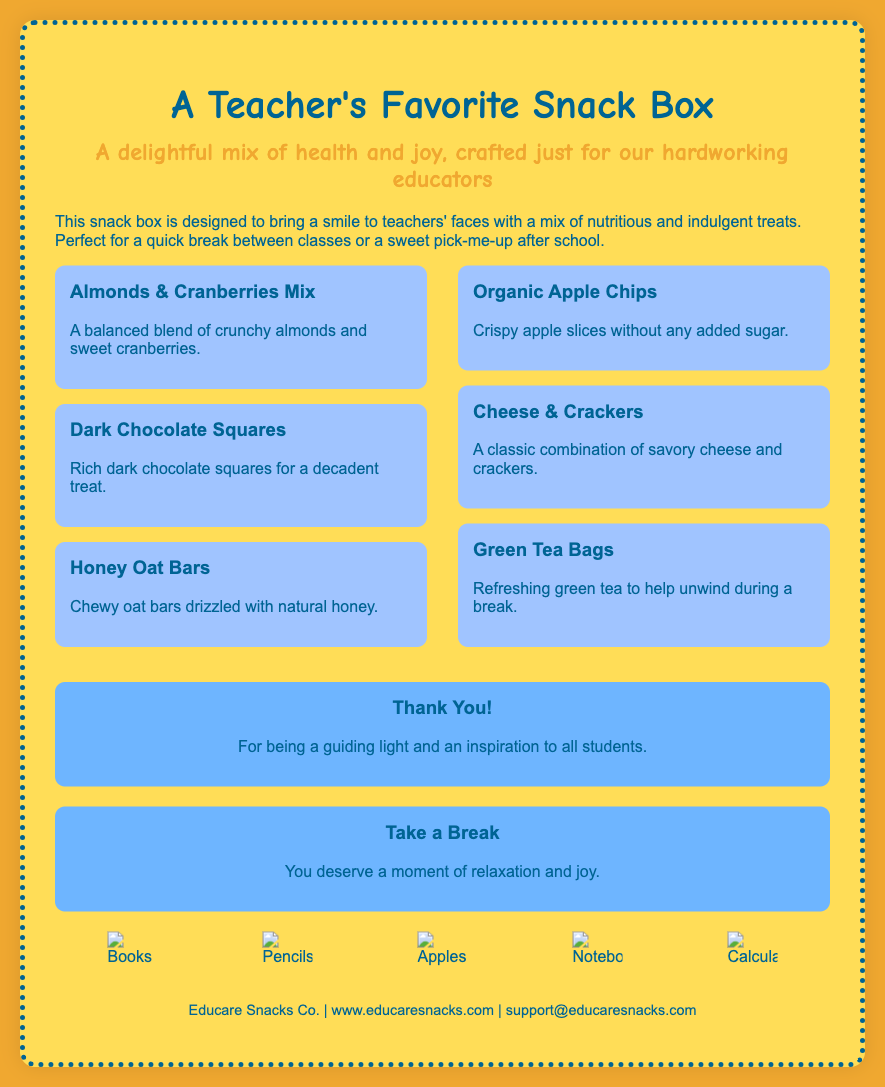What is the name of the product? The product name is prominently displayed as the title of the packaging.
Answer: A Teacher's Favorite Snack Box What type of snacks are included? The document mentions both healthy snacks and treats, specifically listing several snack items.
Answer: Healthy snacks and treats How many snack items are listed in the left column? The left column has three distinct snack items mentioned.
Answer: Three What is one treat included in the box? The packaging describes specific snacks as treats, such as dark chocolate squares.
Answer: Dark Chocolate Squares What color is the background of the snack box? The background color is specified in the styling section of the document.
Answer: Yellow What is a message directed towards teachers? The document includes a message of appreciation directed at teachers.
Answer: Thank You! How many snack items contain fruit? The document identifies two snack items that include fruit (almonds & cranberries mix and organic apple chips).
Answer: Two What is the contact email provided? The contact information section clearly states the email address for support.
Answer: support@educaresnacks.com Which illustration is NOT mentioned in the icons section? The icons section includes several illustrations, and the question asks about any that are not included, such as scissors.
Answer: Scissors 